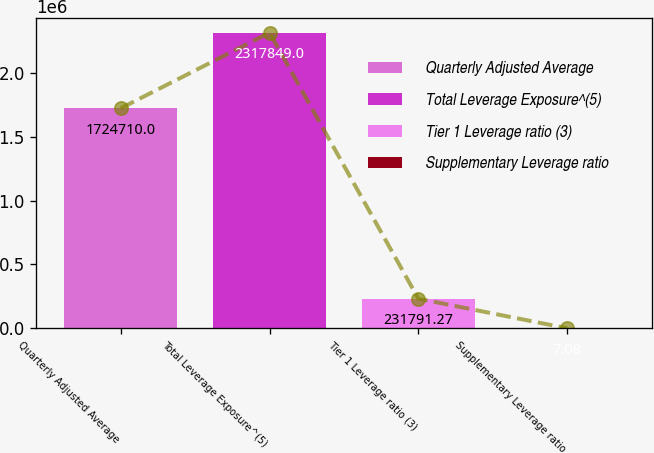Convert chart to OTSL. <chart><loc_0><loc_0><loc_500><loc_500><bar_chart><fcel>Quarterly Adjusted Average<fcel>Total Leverage Exposure^(5)<fcel>Tier 1 Leverage ratio (3)<fcel>Supplementary Leverage ratio<nl><fcel>1.72471e+06<fcel>2.31785e+06<fcel>231791<fcel>7.08<nl></chart> 